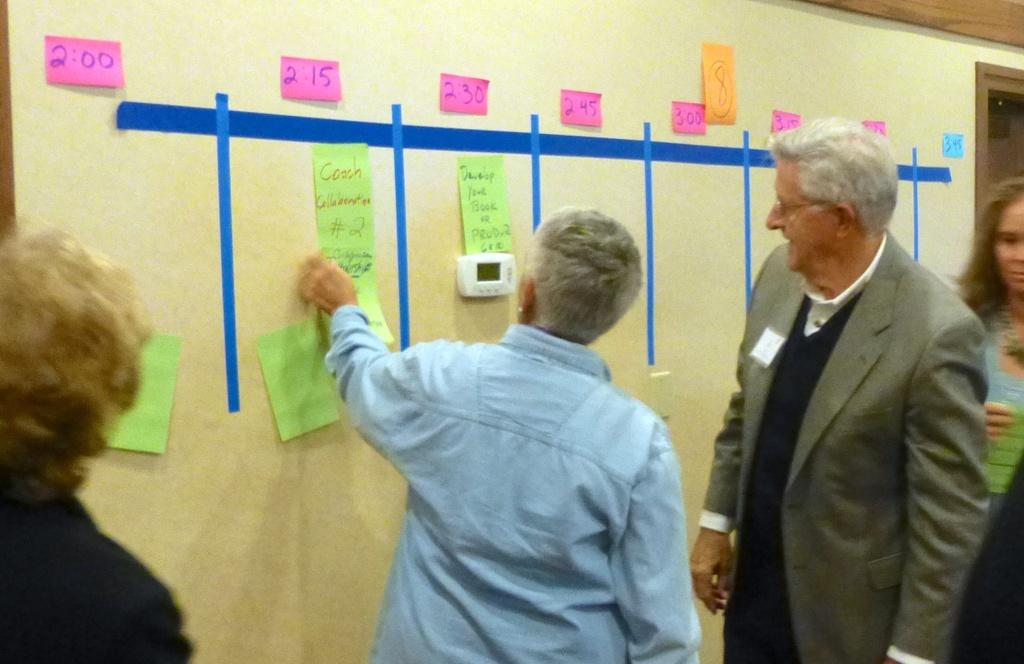Who or what is present in the image? There are people in the image. What are the people doing in the image? The people are standing and looking at papers. Where are the papers located in the image? The papers are stuck on a wall. What type of dress is the clock wearing in the image? There is no clock or dress present in the image. 